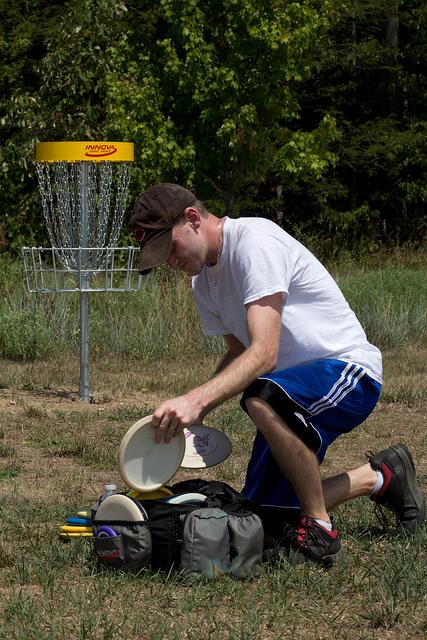Is this man preparing to play ultimate frisbee or disk golf?
Write a very short answer. Disk golf. Is he washing a plate?
Short answer required. No. Is this person preparing to camp?
Answer briefly. No. What type of sporting equipment is the man holding?
Concise answer only. Frisbee. 